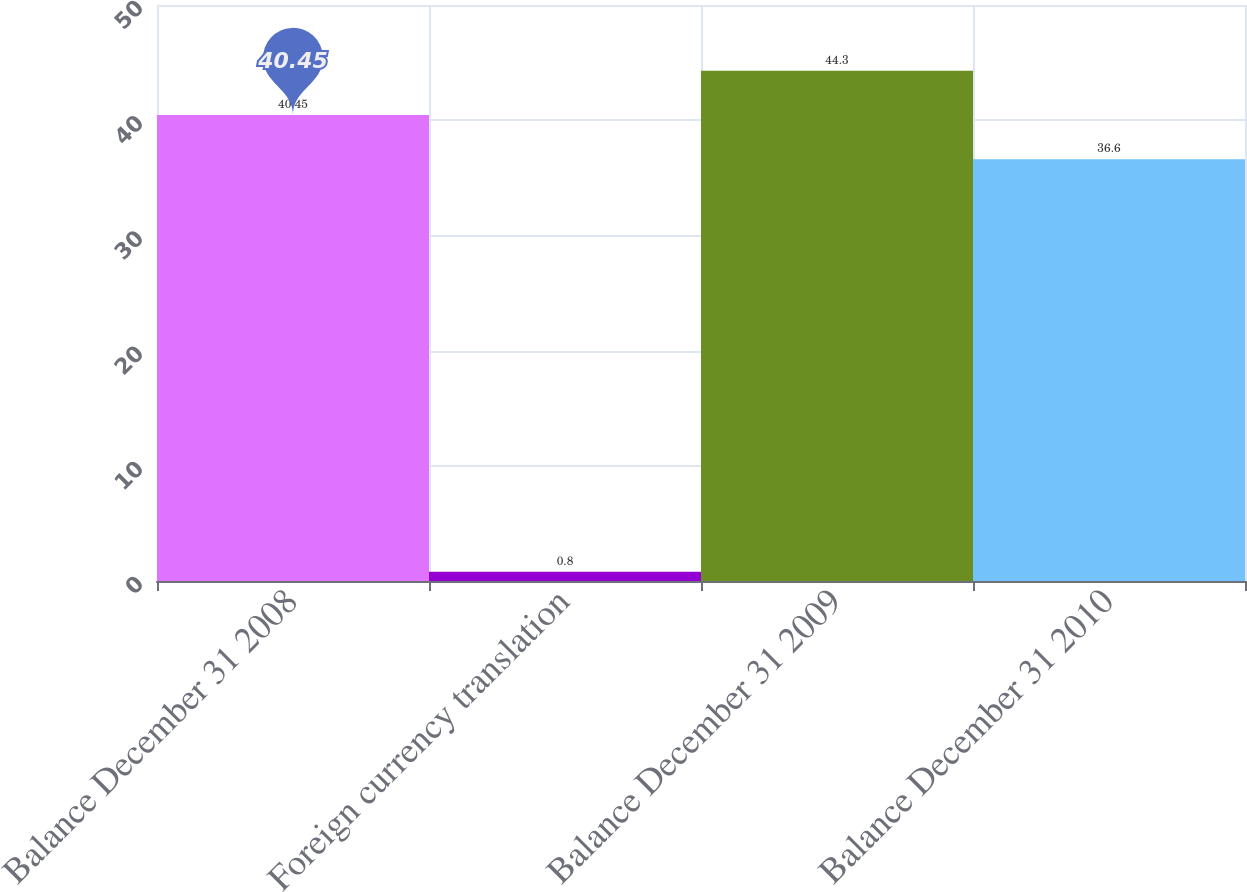<chart> <loc_0><loc_0><loc_500><loc_500><bar_chart><fcel>Balance December 31 2008<fcel>Foreign currency translation<fcel>Balance December 31 2009<fcel>Balance December 31 2010<nl><fcel>40.45<fcel>0.8<fcel>44.3<fcel>36.6<nl></chart> 